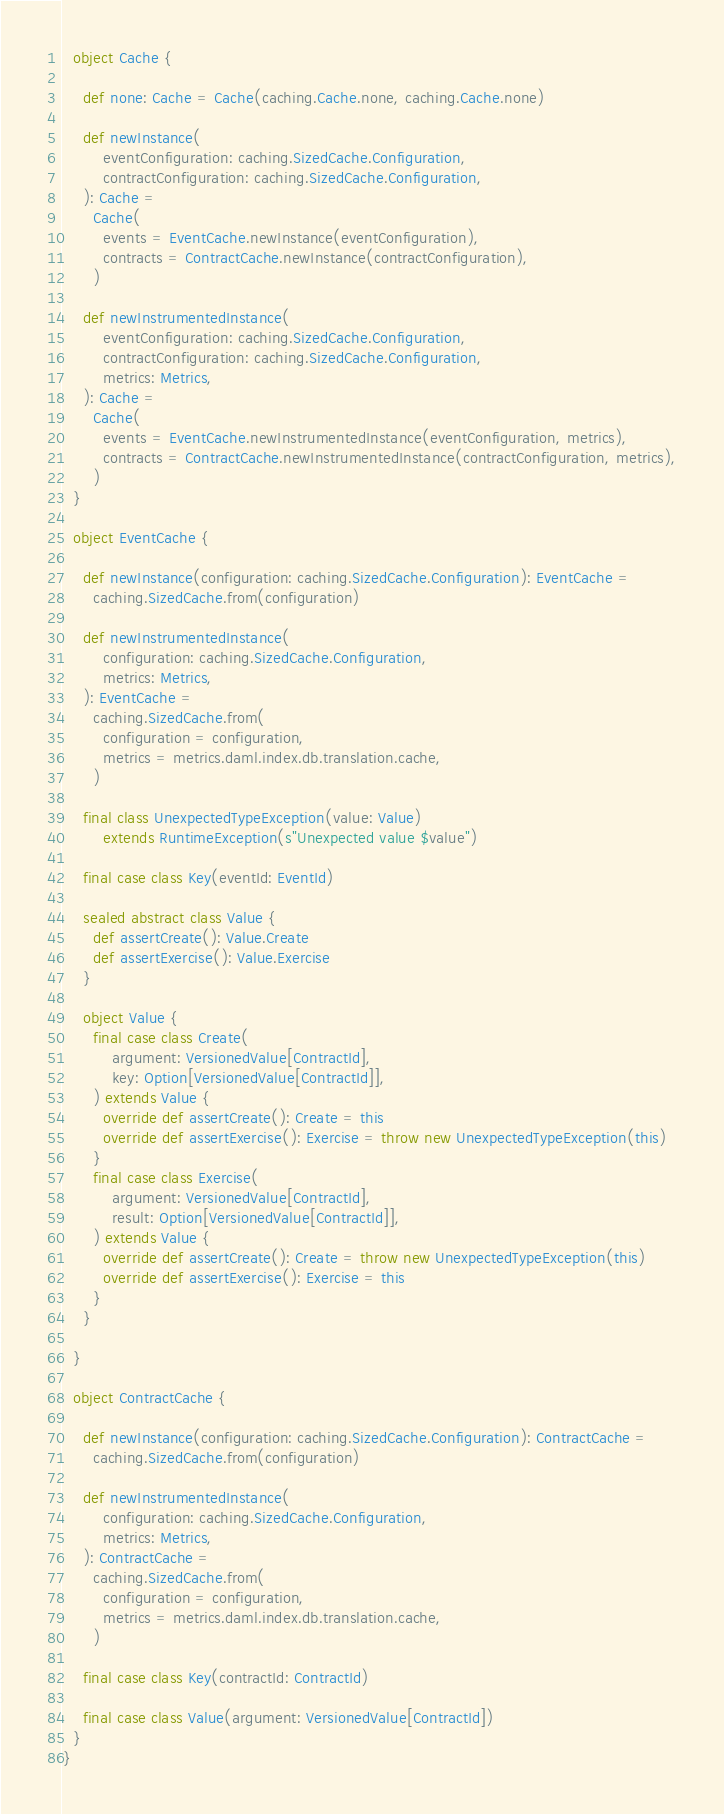Convert code to text. <code><loc_0><loc_0><loc_500><loc_500><_Scala_>
  object Cache {

    def none: Cache = Cache(caching.Cache.none, caching.Cache.none)

    def newInstance(
        eventConfiguration: caching.SizedCache.Configuration,
        contractConfiguration: caching.SizedCache.Configuration,
    ): Cache =
      Cache(
        events = EventCache.newInstance(eventConfiguration),
        contracts = ContractCache.newInstance(contractConfiguration),
      )

    def newInstrumentedInstance(
        eventConfiguration: caching.SizedCache.Configuration,
        contractConfiguration: caching.SizedCache.Configuration,
        metrics: Metrics,
    ): Cache =
      Cache(
        events = EventCache.newInstrumentedInstance(eventConfiguration, metrics),
        contracts = ContractCache.newInstrumentedInstance(contractConfiguration, metrics),
      )
  }

  object EventCache {

    def newInstance(configuration: caching.SizedCache.Configuration): EventCache =
      caching.SizedCache.from(configuration)

    def newInstrumentedInstance(
        configuration: caching.SizedCache.Configuration,
        metrics: Metrics,
    ): EventCache =
      caching.SizedCache.from(
        configuration = configuration,
        metrics = metrics.daml.index.db.translation.cache,
      )

    final class UnexpectedTypeException(value: Value)
        extends RuntimeException(s"Unexpected value $value")

    final case class Key(eventId: EventId)

    sealed abstract class Value {
      def assertCreate(): Value.Create
      def assertExercise(): Value.Exercise
    }

    object Value {
      final case class Create(
          argument: VersionedValue[ContractId],
          key: Option[VersionedValue[ContractId]],
      ) extends Value {
        override def assertCreate(): Create = this
        override def assertExercise(): Exercise = throw new UnexpectedTypeException(this)
      }
      final case class Exercise(
          argument: VersionedValue[ContractId],
          result: Option[VersionedValue[ContractId]],
      ) extends Value {
        override def assertCreate(): Create = throw new UnexpectedTypeException(this)
        override def assertExercise(): Exercise = this
      }
    }

  }

  object ContractCache {

    def newInstance(configuration: caching.SizedCache.Configuration): ContractCache =
      caching.SizedCache.from(configuration)

    def newInstrumentedInstance(
        configuration: caching.SizedCache.Configuration,
        metrics: Metrics,
    ): ContractCache =
      caching.SizedCache.from(
        configuration = configuration,
        metrics = metrics.daml.index.db.translation.cache,
      )

    final case class Key(contractId: ContractId)

    final case class Value(argument: VersionedValue[ContractId])
  }
}
</code> 